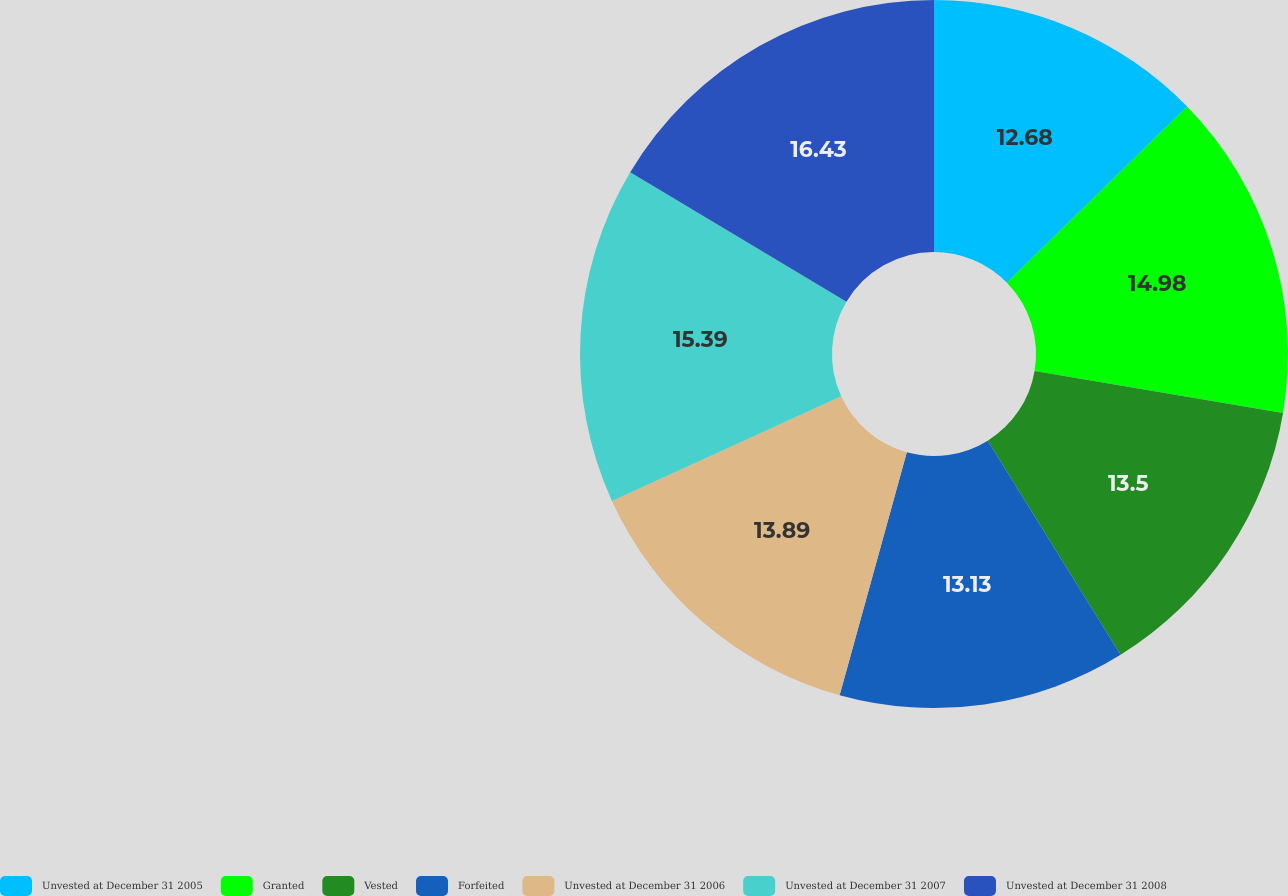Convert chart to OTSL. <chart><loc_0><loc_0><loc_500><loc_500><pie_chart><fcel>Unvested at December 31 2005<fcel>Granted<fcel>Vested<fcel>Forfeited<fcel>Unvested at December 31 2006<fcel>Unvested at December 31 2007<fcel>Unvested at December 31 2008<nl><fcel>12.68%<fcel>14.98%<fcel>13.5%<fcel>13.13%<fcel>13.89%<fcel>15.39%<fcel>16.42%<nl></chart> 